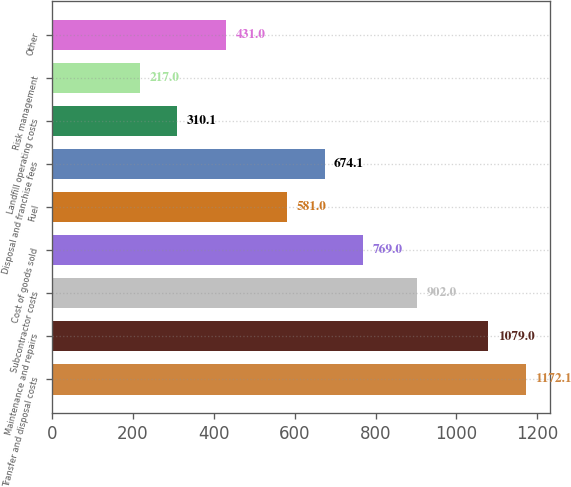Convert chart to OTSL. <chart><loc_0><loc_0><loc_500><loc_500><bar_chart><fcel>Transfer and disposal costs<fcel>Maintenance and repairs<fcel>Subcontractor costs<fcel>Cost of goods sold<fcel>Fuel<fcel>Disposal and franchise fees<fcel>Landfill operating costs<fcel>Risk management<fcel>Other<nl><fcel>1172.1<fcel>1079<fcel>902<fcel>769<fcel>581<fcel>674.1<fcel>310.1<fcel>217<fcel>431<nl></chart> 